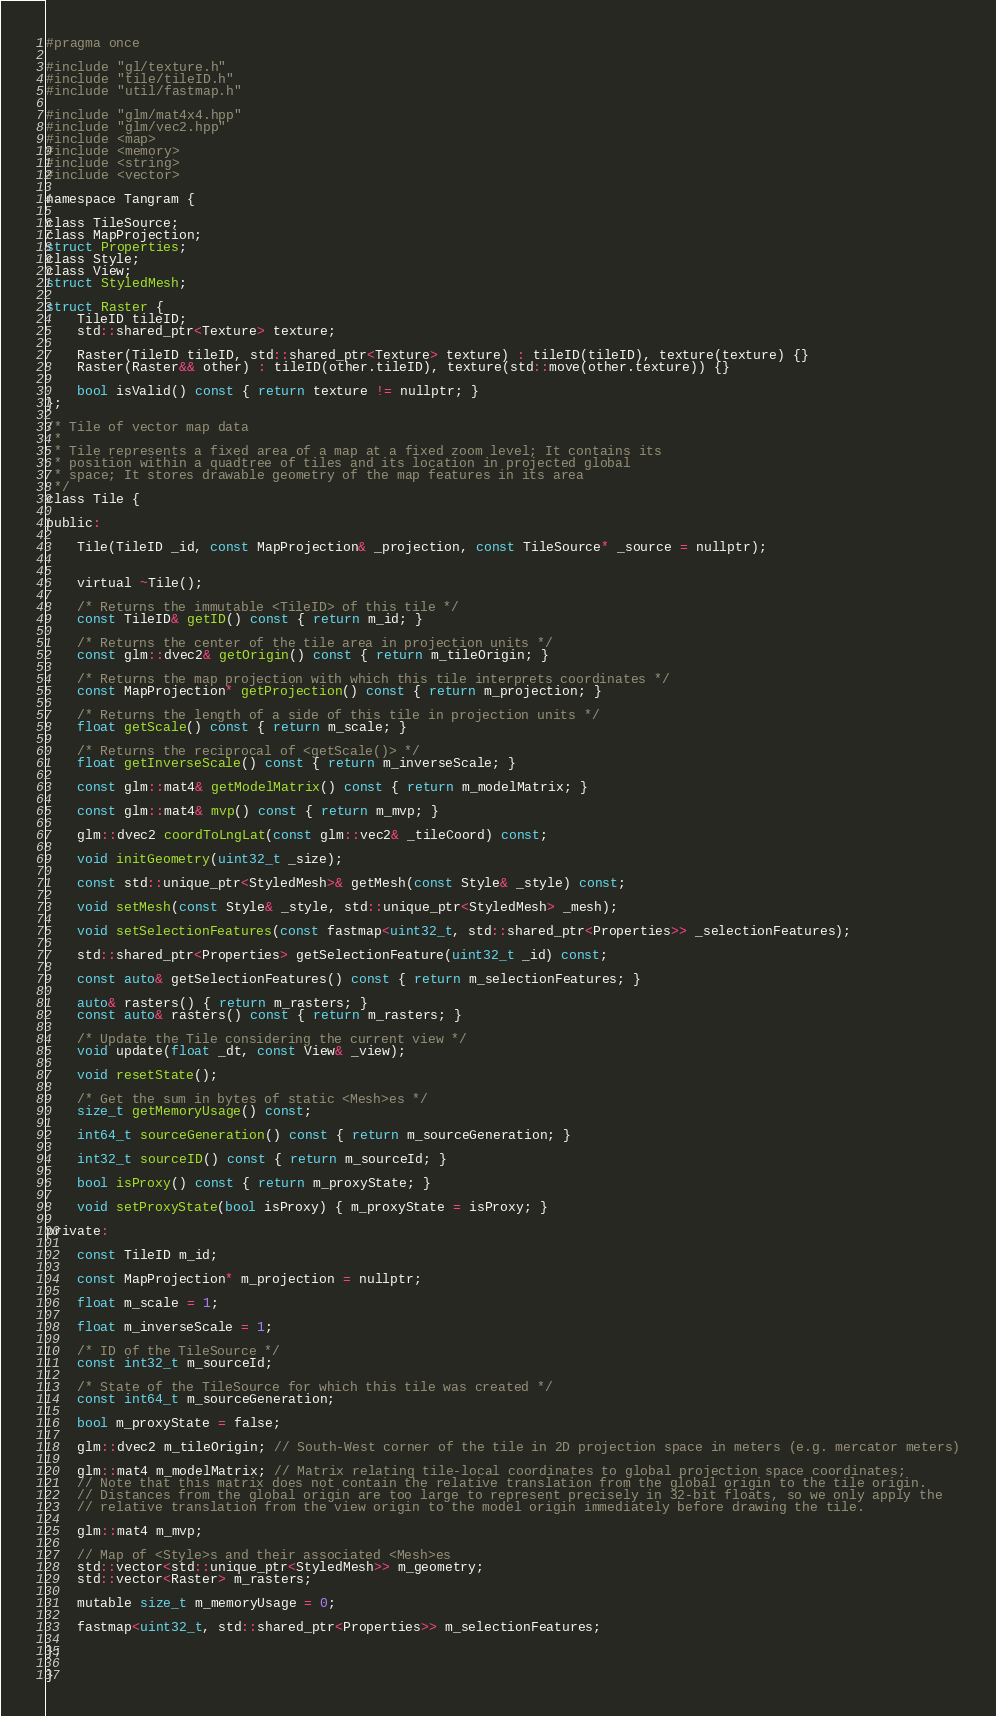<code> <loc_0><loc_0><loc_500><loc_500><_C_>#pragma once

#include "gl/texture.h"
#include "tile/tileID.h"
#include "util/fastmap.h"

#include "glm/mat4x4.hpp"
#include "glm/vec2.hpp"
#include <map>
#include <memory>
#include <string>
#include <vector>

namespace Tangram {

class TileSource;
class MapProjection;
struct Properties;
class Style;
class View;
struct StyledMesh;

struct Raster {
    TileID tileID;
    std::shared_ptr<Texture> texture;

    Raster(TileID tileID, std::shared_ptr<Texture> texture) : tileID(tileID), texture(texture) {}
    Raster(Raster&& other) : tileID(other.tileID), texture(std::move(other.texture)) {}

    bool isValid() const { return texture != nullptr; }
};

/* Tile of vector map data
 *
 * Tile represents a fixed area of a map at a fixed zoom level; It contains its
 * position within a quadtree of tiles and its location in projected global
 * space; It stores drawable geometry of the map features in its area
 */
class Tile {

public:

    Tile(TileID _id, const MapProjection& _projection, const TileSource* _source = nullptr);


    virtual ~Tile();

    /* Returns the immutable <TileID> of this tile */
    const TileID& getID() const { return m_id; }

    /* Returns the center of the tile area in projection units */
    const glm::dvec2& getOrigin() const { return m_tileOrigin; }

    /* Returns the map projection with which this tile interprets coordinates */
    const MapProjection* getProjection() const { return m_projection; }

    /* Returns the length of a side of this tile in projection units */
    float getScale() const { return m_scale; }

    /* Returns the reciprocal of <getScale()> */
    float getInverseScale() const { return m_inverseScale; }

    const glm::mat4& getModelMatrix() const { return m_modelMatrix; }

    const glm::mat4& mvp() const { return m_mvp; }

    glm::dvec2 coordToLngLat(const glm::vec2& _tileCoord) const;

    void initGeometry(uint32_t _size);

    const std::unique_ptr<StyledMesh>& getMesh(const Style& _style) const;

    void setMesh(const Style& _style, std::unique_ptr<StyledMesh> _mesh);

    void setSelectionFeatures(const fastmap<uint32_t, std::shared_ptr<Properties>> _selectionFeatures);

    std::shared_ptr<Properties> getSelectionFeature(uint32_t _id) const;

    const auto& getSelectionFeatures() const { return m_selectionFeatures; }

    auto& rasters() { return m_rasters; }
    const auto& rasters() const { return m_rasters; }

    /* Update the Tile considering the current view */
    void update(float _dt, const View& _view);

    void resetState();

    /* Get the sum in bytes of static <Mesh>es */
    size_t getMemoryUsage() const;

    int64_t sourceGeneration() const { return m_sourceGeneration; }

    int32_t sourceID() const { return m_sourceId; }

    bool isProxy() const { return m_proxyState; }

    void setProxyState(bool isProxy) { m_proxyState = isProxy; }

private:

    const TileID m_id;

    const MapProjection* m_projection = nullptr;

    float m_scale = 1;

    float m_inverseScale = 1;

    /* ID of the TileSource */
    const int32_t m_sourceId;

    /* State of the TileSource for which this tile was created */
    const int64_t m_sourceGeneration;

    bool m_proxyState = false;

    glm::dvec2 m_tileOrigin; // South-West corner of the tile in 2D projection space in meters (e.g. mercator meters)

    glm::mat4 m_modelMatrix; // Matrix relating tile-local coordinates to global projection space coordinates;
    // Note that this matrix does not contain the relative translation from the global origin to the tile origin.
    // Distances from the global origin are too large to represent precisely in 32-bit floats, so we only apply the
    // relative translation from the view origin to the model origin immediately before drawing the tile.

    glm::mat4 m_mvp;

    // Map of <Style>s and their associated <Mesh>es
    std::vector<std::unique_ptr<StyledMesh>> m_geometry;
    std::vector<Raster> m_rasters;

    mutable size_t m_memoryUsage = 0;

    fastmap<uint32_t, std::shared_ptr<Properties>> m_selectionFeatures;

};

}
</code> 